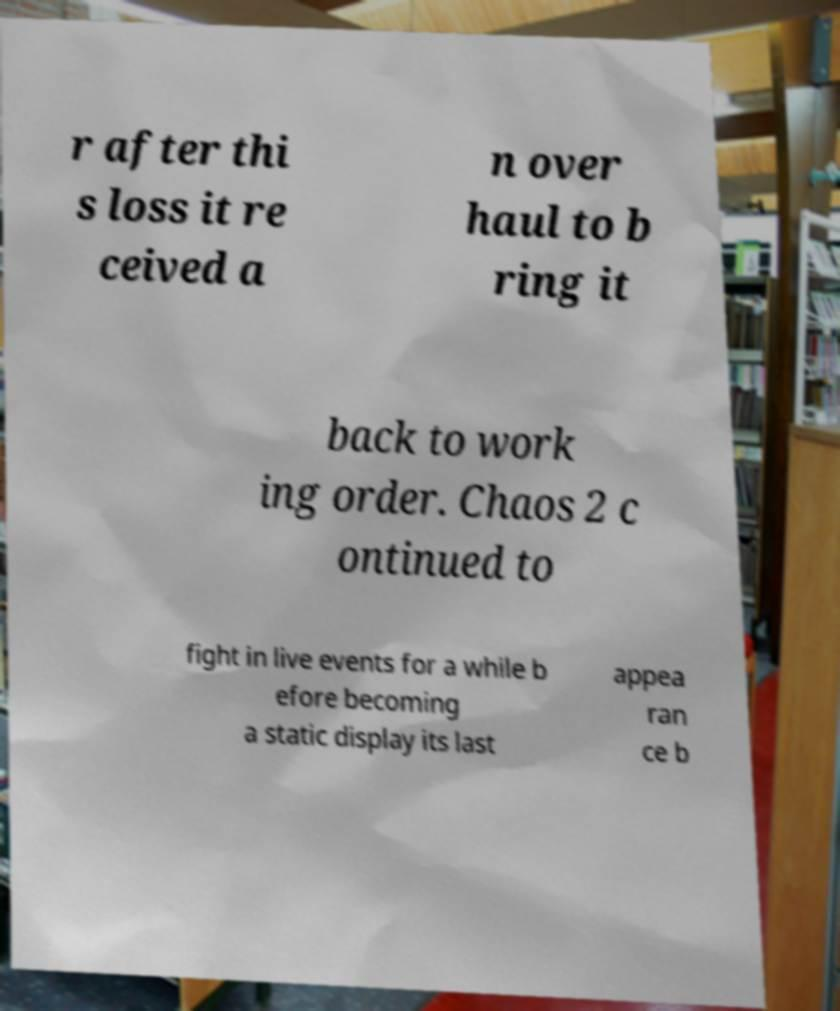Please read and relay the text visible in this image. What does it say? r after thi s loss it re ceived a n over haul to b ring it back to work ing order. Chaos 2 c ontinued to fight in live events for a while b efore becoming a static display its last appea ran ce b 